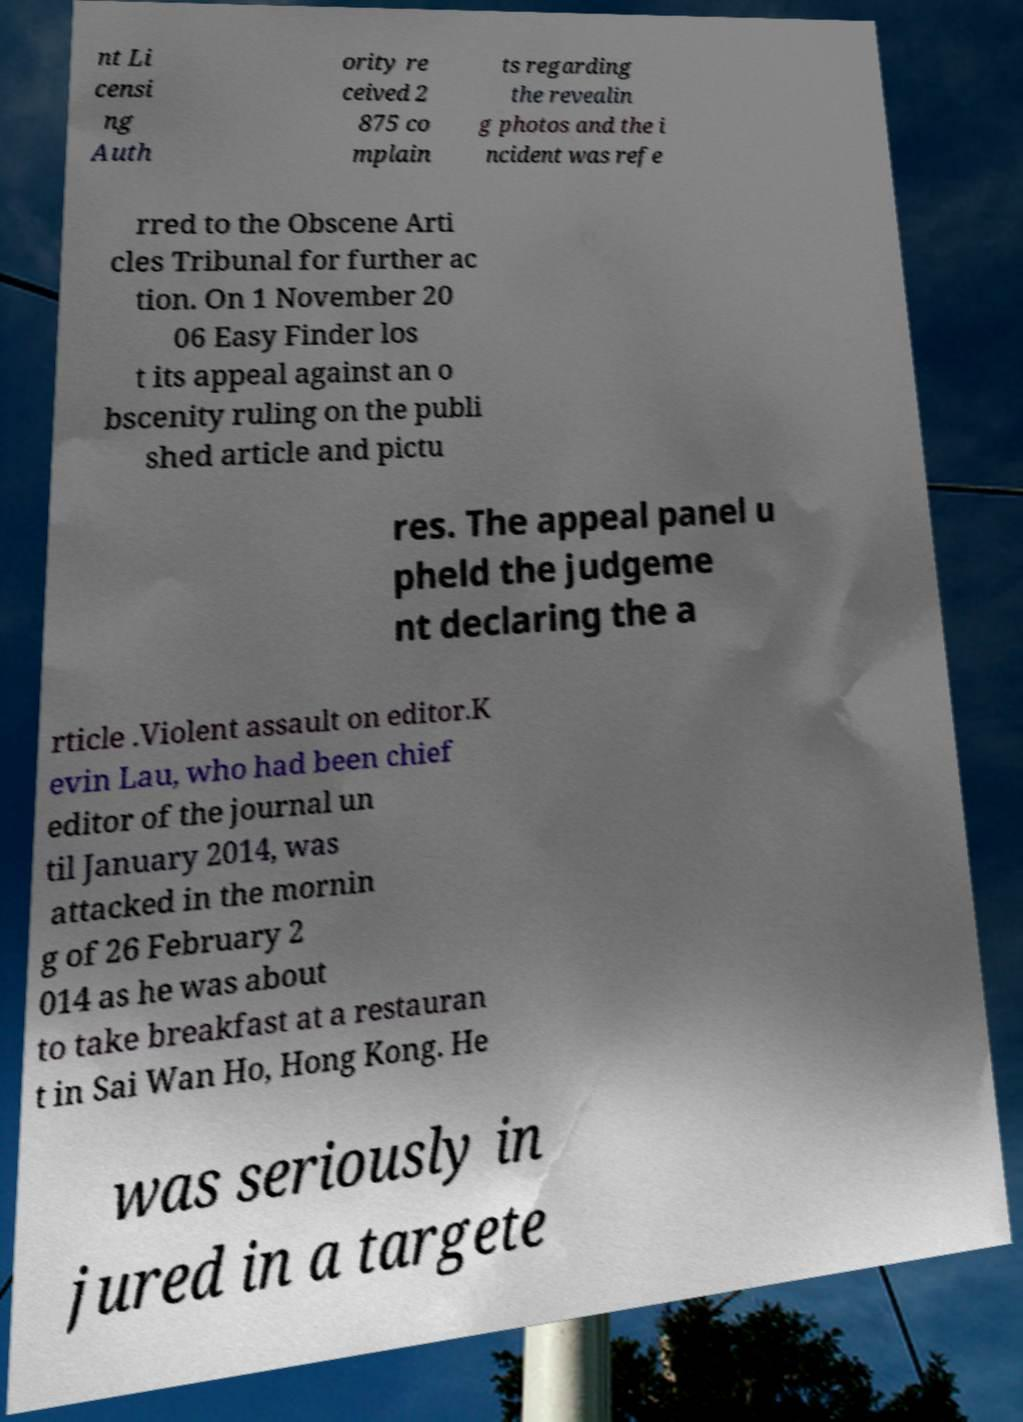Could you assist in decoding the text presented in this image and type it out clearly? nt Li censi ng Auth ority re ceived 2 875 co mplain ts regarding the revealin g photos and the i ncident was refe rred to the Obscene Arti cles Tribunal for further ac tion. On 1 November 20 06 Easy Finder los t its appeal against an o bscenity ruling on the publi shed article and pictu res. The appeal panel u pheld the judgeme nt declaring the a rticle .Violent assault on editor.K evin Lau, who had been chief editor of the journal un til January 2014, was attacked in the mornin g of 26 February 2 014 as he was about to take breakfast at a restauran t in Sai Wan Ho, Hong Kong. He was seriously in jured in a targete 